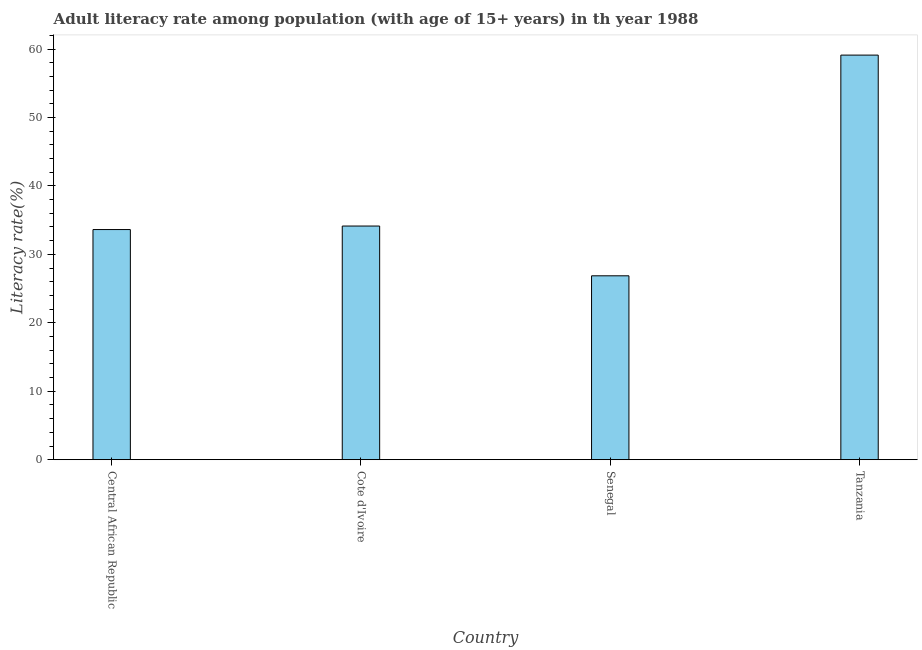Does the graph contain any zero values?
Provide a succinct answer. No. What is the title of the graph?
Offer a terse response. Adult literacy rate among population (with age of 15+ years) in th year 1988. What is the label or title of the Y-axis?
Your answer should be compact. Literacy rate(%). What is the adult literacy rate in Central African Republic?
Offer a very short reply. 33.62. Across all countries, what is the maximum adult literacy rate?
Make the answer very short. 59.11. Across all countries, what is the minimum adult literacy rate?
Provide a short and direct response. 26.87. In which country was the adult literacy rate maximum?
Provide a succinct answer. Tanzania. In which country was the adult literacy rate minimum?
Offer a very short reply. Senegal. What is the sum of the adult literacy rate?
Provide a succinct answer. 153.75. What is the difference between the adult literacy rate in Central African Republic and Senegal?
Your answer should be compact. 6.76. What is the average adult literacy rate per country?
Offer a terse response. 38.44. What is the median adult literacy rate?
Your answer should be compact. 33.88. In how many countries, is the adult literacy rate greater than 36 %?
Offer a terse response. 1. What is the ratio of the adult literacy rate in Central African Republic to that in Cote d'Ivoire?
Give a very brief answer. 0.98. Is the adult literacy rate in Central African Republic less than that in Cote d'Ivoire?
Your answer should be compact. Yes. What is the difference between the highest and the second highest adult literacy rate?
Your answer should be compact. 24.98. Is the sum of the adult literacy rate in Central African Republic and Tanzania greater than the maximum adult literacy rate across all countries?
Your answer should be very brief. Yes. What is the difference between the highest and the lowest adult literacy rate?
Your answer should be very brief. 32.24. In how many countries, is the adult literacy rate greater than the average adult literacy rate taken over all countries?
Give a very brief answer. 1. Are all the bars in the graph horizontal?
Offer a terse response. No. How many countries are there in the graph?
Offer a terse response. 4. What is the difference between two consecutive major ticks on the Y-axis?
Your answer should be compact. 10. What is the Literacy rate(%) of Central African Republic?
Make the answer very short. 33.62. What is the Literacy rate(%) of Cote d'Ivoire?
Provide a short and direct response. 34.14. What is the Literacy rate(%) of Senegal?
Ensure brevity in your answer.  26.87. What is the Literacy rate(%) of Tanzania?
Your response must be concise. 59.11. What is the difference between the Literacy rate(%) in Central African Republic and Cote d'Ivoire?
Your answer should be compact. -0.51. What is the difference between the Literacy rate(%) in Central African Republic and Senegal?
Keep it short and to the point. 6.76. What is the difference between the Literacy rate(%) in Central African Republic and Tanzania?
Offer a terse response. -25.49. What is the difference between the Literacy rate(%) in Cote d'Ivoire and Senegal?
Ensure brevity in your answer.  7.27. What is the difference between the Literacy rate(%) in Cote d'Ivoire and Tanzania?
Keep it short and to the point. -24.97. What is the difference between the Literacy rate(%) in Senegal and Tanzania?
Give a very brief answer. -32.24. What is the ratio of the Literacy rate(%) in Central African Republic to that in Cote d'Ivoire?
Your response must be concise. 0.98. What is the ratio of the Literacy rate(%) in Central African Republic to that in Senegal?
Your answer should be compact. 1.25. What is the ratio of the Literacy rate(%) in Central African Republic to that in Tanzania?
Your response must be concise. 0.57. What is the ratio of the Literacy rate(%) in Cote d'Ivoire to that in Senegal?
Provide a short and direct response. 1.27. What is the ratio of the Literacy rate(%) in Cote d'Ivoire to that in Tanzania?
Offer a very short reply. 0.58. What is the ratio of the Literacy rate(%) in Senegal to that in Tanzania?
Your response must be concise. 0.46. 